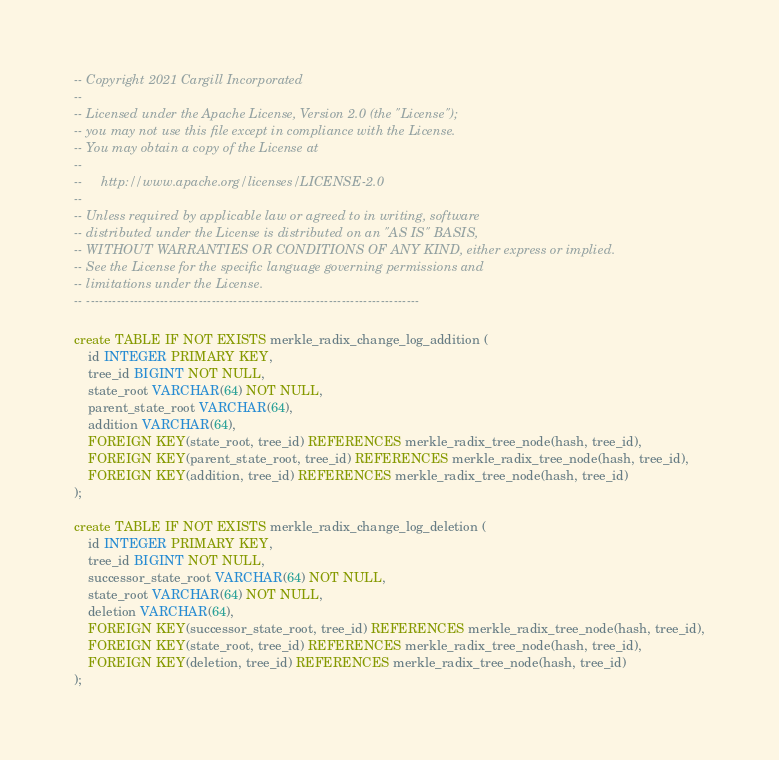<code> <loc_0><loc_0><loc_500><loc_500><_SQL_>-- Copyright 2021 Cargill Incorporated
--
-- Licensed under the Apache License, Version 2.0 (the "License");
-- you may not use this file except in compliance with the License.
-- You may obtain a copy of the License at
--
--     http://www.apache.org/licenses/LICENSE-2.0
--
-- Unless required by applicable law or agreed to in writing, software
-- distributed under the License is distributed on an "AS IS" BASIS,
-- WITHOUT WARRANTIES OR CONDITIONS OF ANY KIND, either express or implied.
-- See the License for the specific language governing permissions and
-- limitations under the License.
-- -----------------------------------------------------------------------------

create TABLE IF NOT EXISTS merkle_radix_change_log_addition (
    id INTEGER PRIMARY KEY,
    tree_id BIGINT NOT NULL,
    state_root VARCHAR(64) NOT NULL,
    parent_state_root VARCHAR(64),
    addition VARCHAR(64),
    FOREIGN KEY(state_root, tree_id) REFERENCES merkle_radix_tree_node(hash, tree_id),
    FOREIGN KEY(parent_state_root, tree_id) REFERENCES merkle_radix_tree_node(hash, tree_id),
    FOREIGN KEY(addition, tree_id) REFERENCES merkle_radix_tree_node(hash, tree_id)
);

create TABLE IF NOT EXISTS merkle_radix_change_log_deletion (
    id INTEGER PRIMARY KEY,
    tree_id BIGINT NOT NULL,
    successor_state_root VARCHAR(64) NOT NULL,
    state_root VARCHAR(64) NOT NULL,
    deletion VARCHAR(64),
    FOREIGN KEY(successor_state_root, tree_id) REFERENCES merkle_radix_tree_node(hash, tree_id),
    FOREIGN KEY(state_root, tree_id) REFERENCES merkle_radix_tree_node(hash, tree_id),
    FOREIGN KEY(deletion, tree_id) REFERENCES merkle_radix_tree_node(hash, tree_id)
);
</code> 